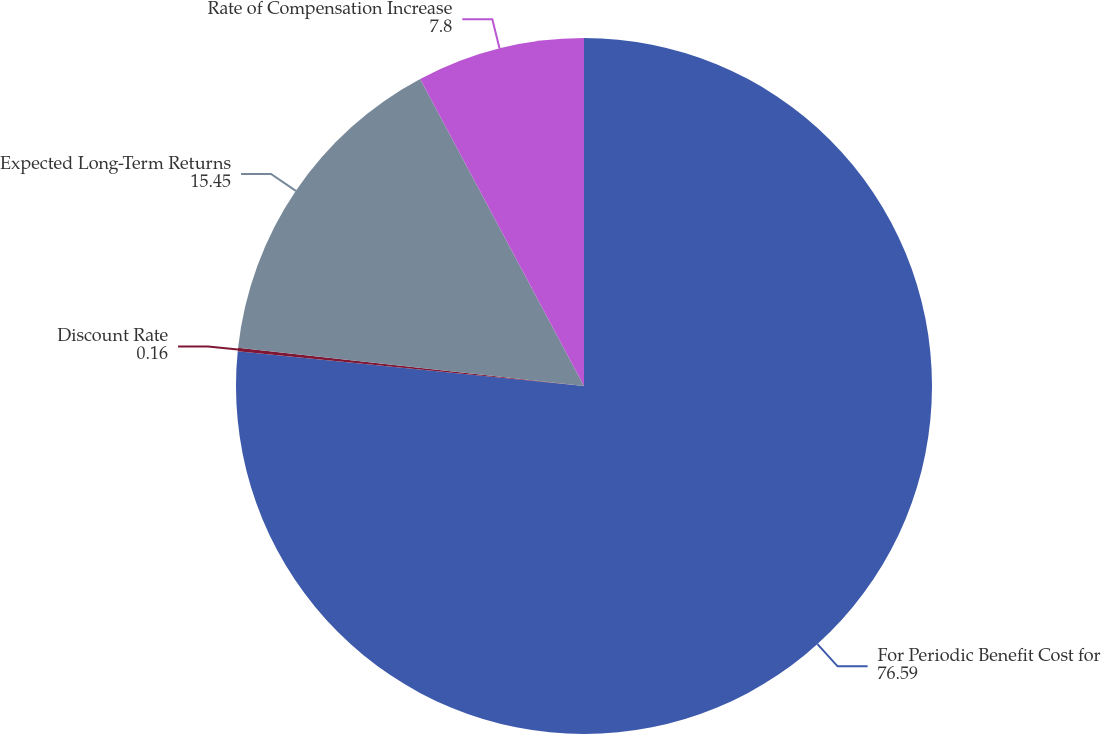Convert chart. <chart><loc_0><loc_0><loc_500><loc_500><pie_chart><fcel>For Periodic Benefit Cost for<fcel>Discount Rate<fcel>Expected Long-Term Returns<fcel>Rate of Compensation Increase<nl><fcel>76.59%<fcel>0.16%<fcel>15.45%<fcel>7.8%<nl></chart> 